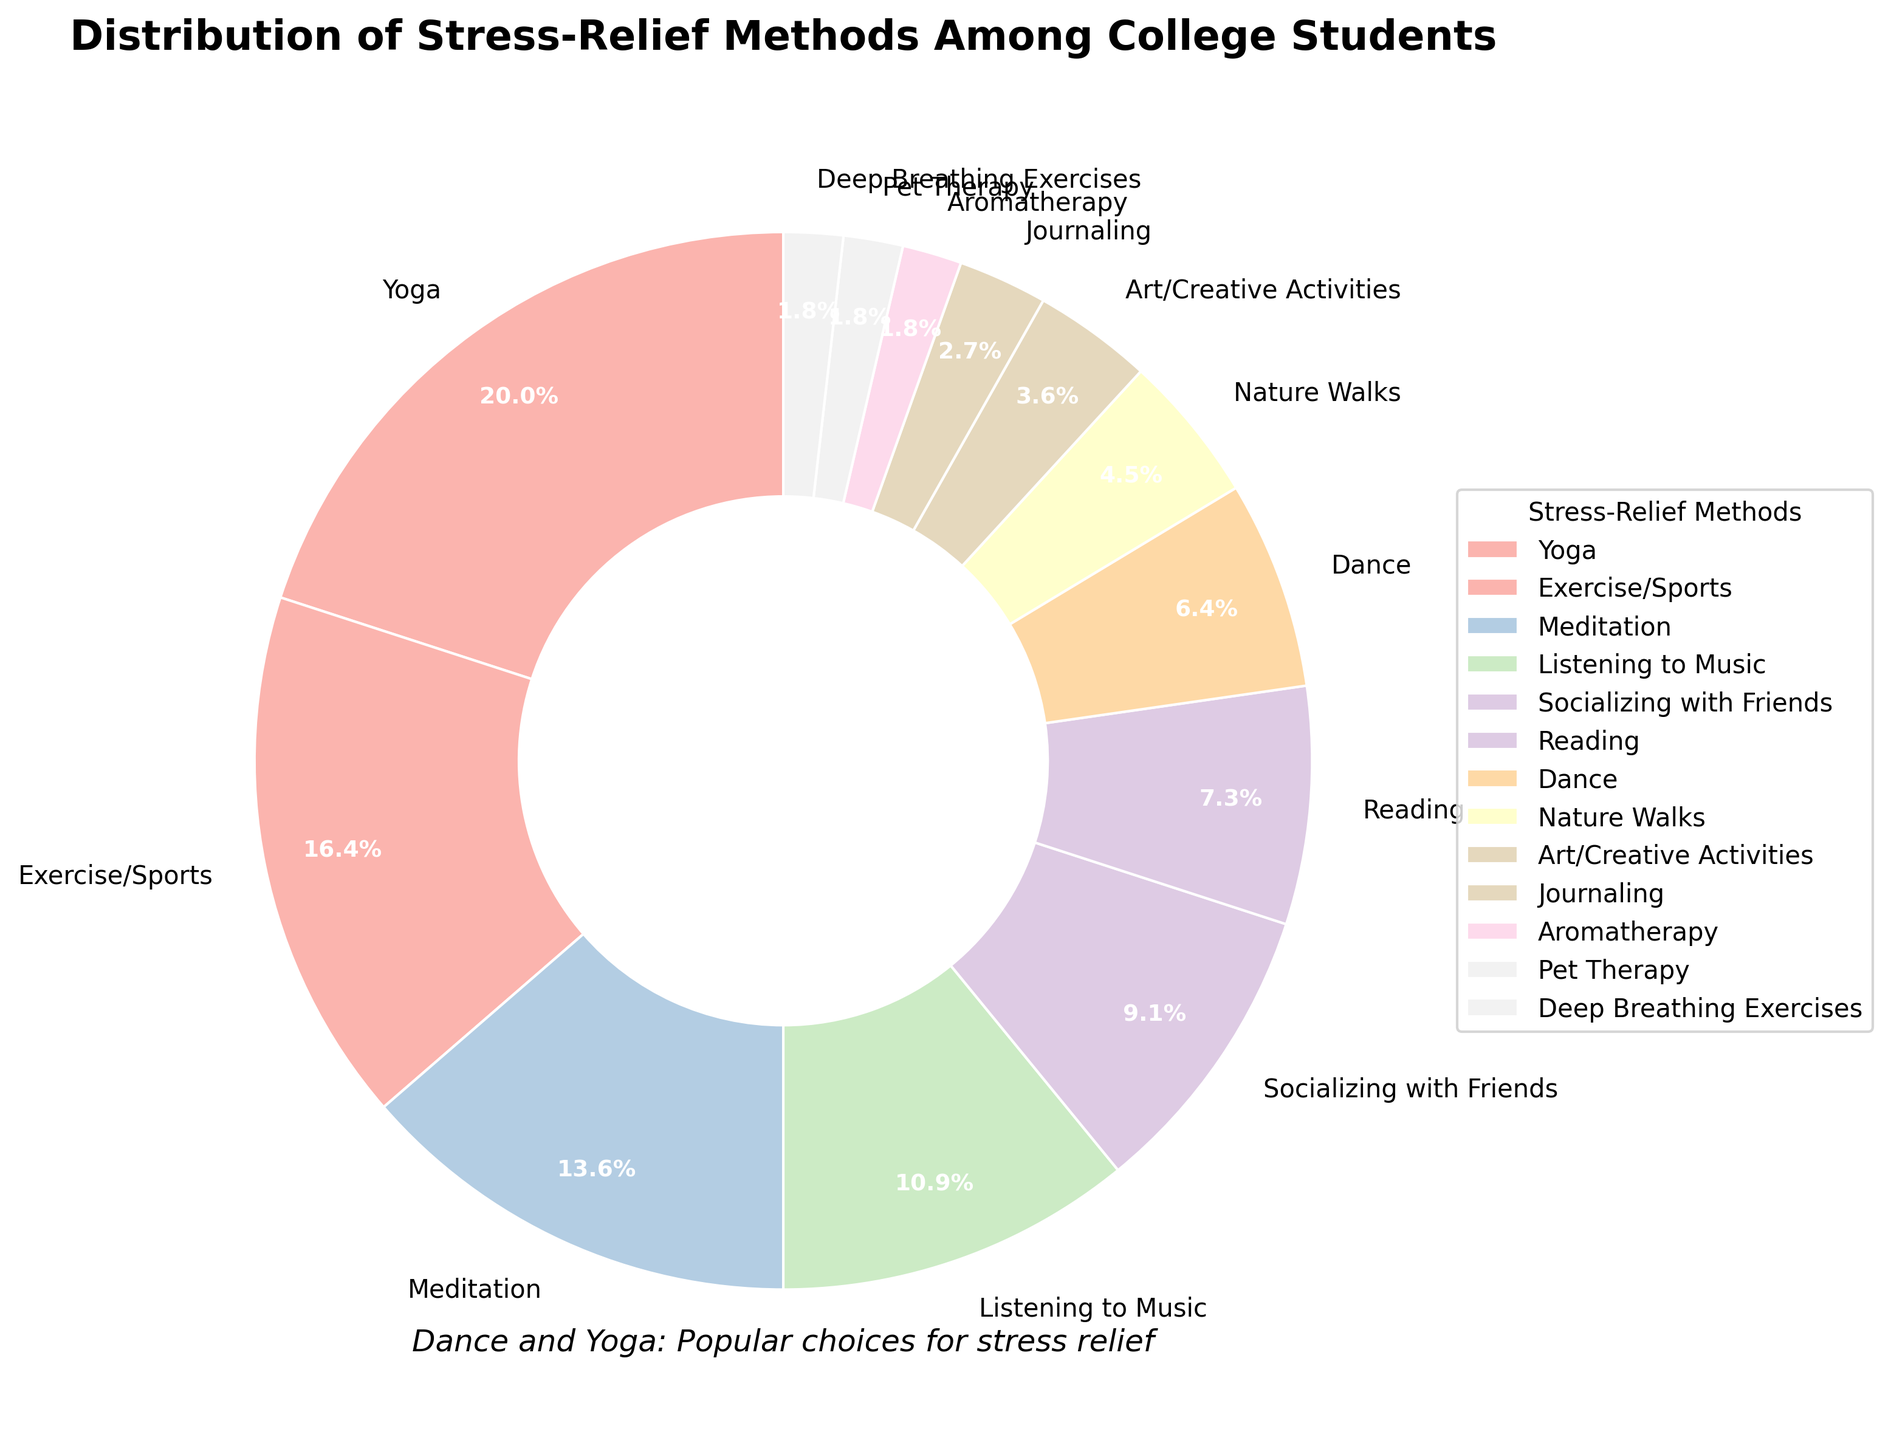What stress-relief method has the highest percentage? By looking at the figure, the method with the largest section of the pie chart represents the highest percentage. From the chart, Yoga has the largest section at 22%.
Answer: Yoga What percentage of college students prefer Exercise/Sports over Meditation? By comparing the percentages of Exercise/Sports and Meditation sections, Exercise/Sports has 18% and Meditation has 15%. The percentage preference is 18% - 15% = 3%.
Answer: 3% How many stress-relief methods are used by at least 10% of the college students? By examining the pie chart, count the methods with equal to or greater than 10%: Yoga (22%), Exercise/Sports (18%), Meditation (15%), Listening to Music (12%), and Socializing with Friends (10%). That's five methods in total.
Answer: 5 Is Reading more popular than Dance as a stress-relief method among college students? By comparing the sizes of the sections for Reading (8%) and Dance (7%), Reading has a higher percentage than Dance.
Answer: Yes What is the combined percentage for the three least popular stress-relief methods? By identifying the three smallest sections and summing their percentages: Aromatherapy (2%), Pet Therapy (2%), and Deep Breathing Exercises (2%). Combined percentage is 2% + 2% + 2% = 6%.
Answer: 6% Which section appears the most colorful visually? The visual aspect of the pie chart indicates that each section has distinct pastel colors. The question is subjective, so a logical choice is the section with a notable hue. Dance, represented with a pastel color, stands out.
Answer: Dance Summarize the percentage of students engaging in nature-related stress-relief activities (Nature Walks, Pet Therapy, Aromatherapy)? By summing up the percentages for Nature Walks (5%), Pet Therapy (2%), and Aromatherapy (2%): 5% + 2% + 2% = 9%.
Answer: 9% Does the proportion of students practicing Yoga exceed those practicing combined Art/Creative Activities, Journaling, and Deep Breathing Exercises? Yoga is 22%, while the sum of Art/Creative Activities (4%), Journaling (3%), and Deep Breathing Exercises (2%) is 4% + 3% + 2% = 9%. Therefore, yes, 22% exceeds 9%.
Answer: Yes What stress-relief methods have an equal percentage share among college students? By observing the pie chart, the methods with equal percentages are Aromatherapy, Pet Therapy, and Deep Breathing Exercises, all at 2%.
Answer: Aromatherapy, Pet Therapy, Deep Breathing Exercises 